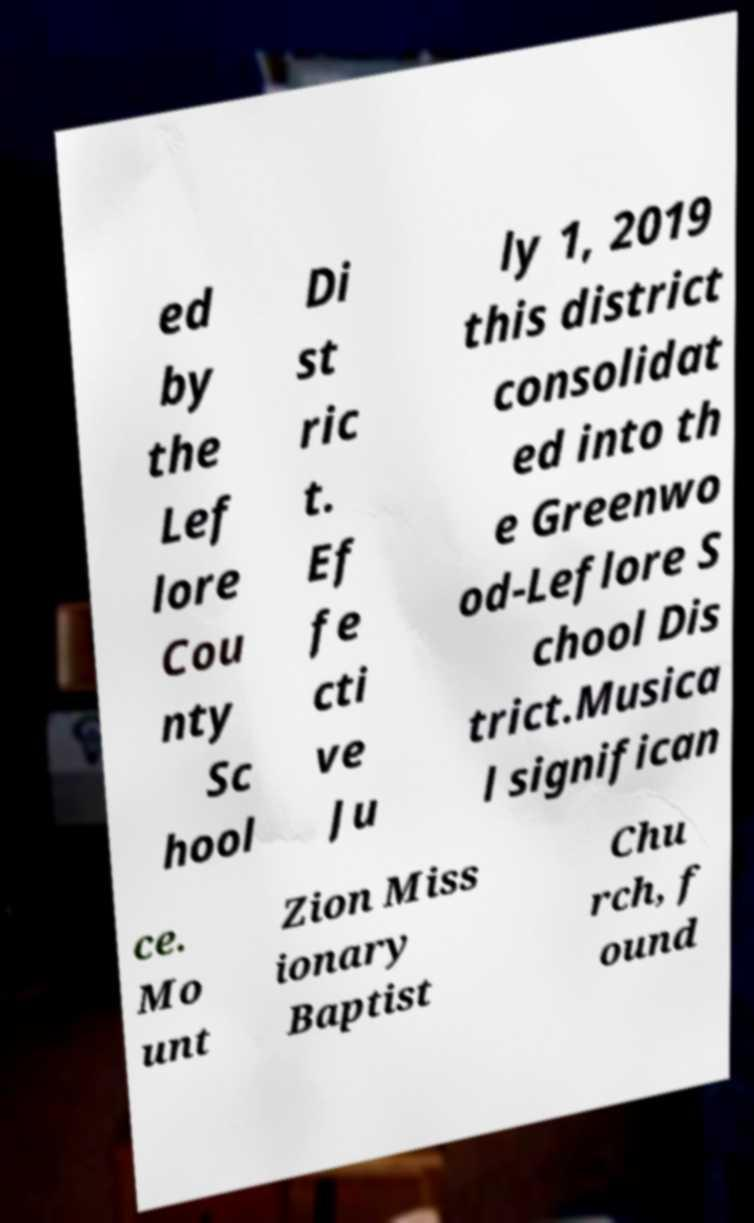There's text embedded in this image that I need extracted. Can you transcribe it verbatim? ed by the Lef lore Cou nty Sc hool Di st ric t. Ef fe cti ve Ju ly 1, 2019 this district consolidat ed into th e Greenwo od-Leflore S chool Dis trict.Musica l significan ce. Mo unt Zion Miss ionary Baptist Chu rch, f ound 